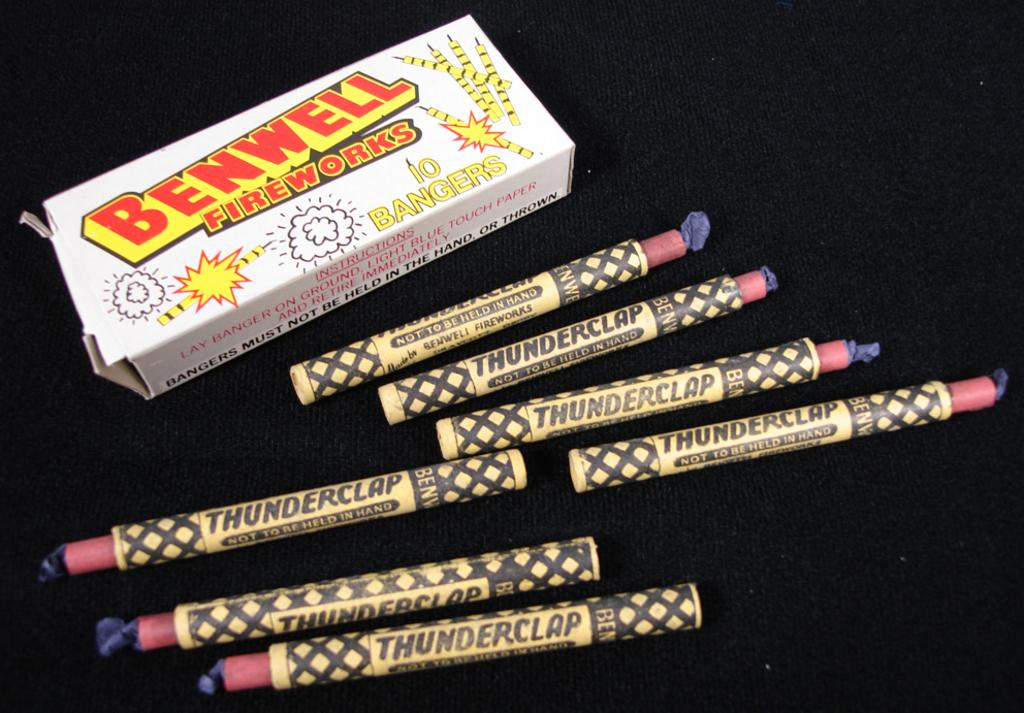<image>
Share a concise interpretation of the image provided. seven benwell fireworks labeled as 'thunderclap' on them 